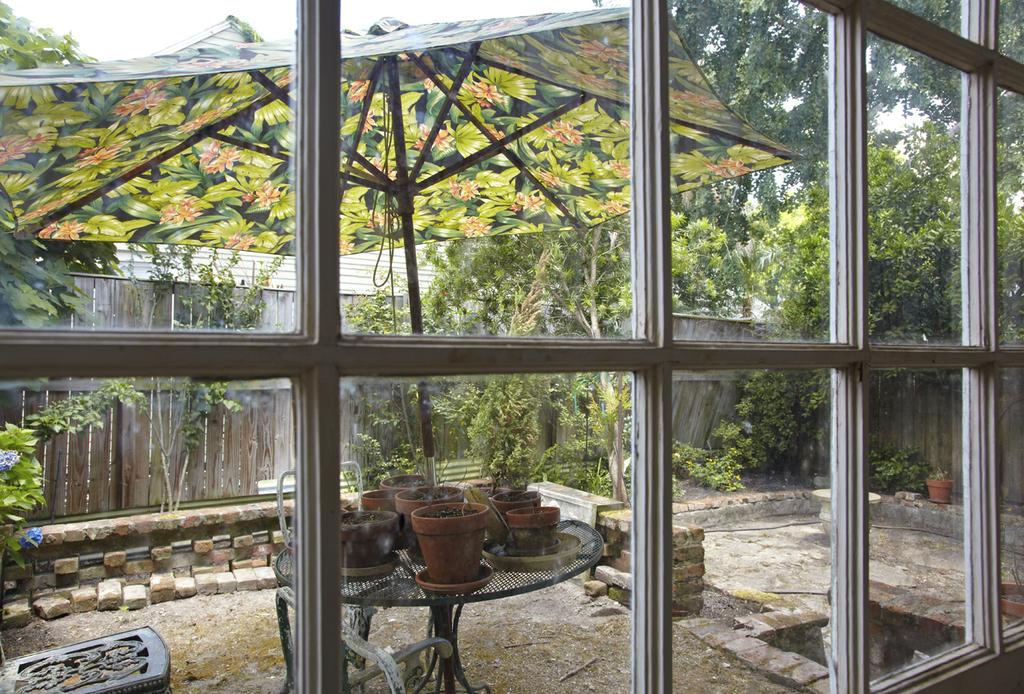What is located in the foreground of the image? There are windows in the foreground of the image. What objects are on the table in the image? There are plant pots on a table. What item is used for protection from rain in the image? There is an umbrella in the image. What material is used for the wall in the image? There is a wooden wall in the image. What type of vegetation is visible in the background of the image? Trees are present in the background of the image. What is visible in the sky in the image? The sky is visible in the background of the image. What type of fact can be seen on the skin of the person in the image? There is no person present in the image, and therefore no skin or facts on skin can be observed. Who is the friend of the person in the image? There is no person present in the image, and therefore no friend can be identified. 